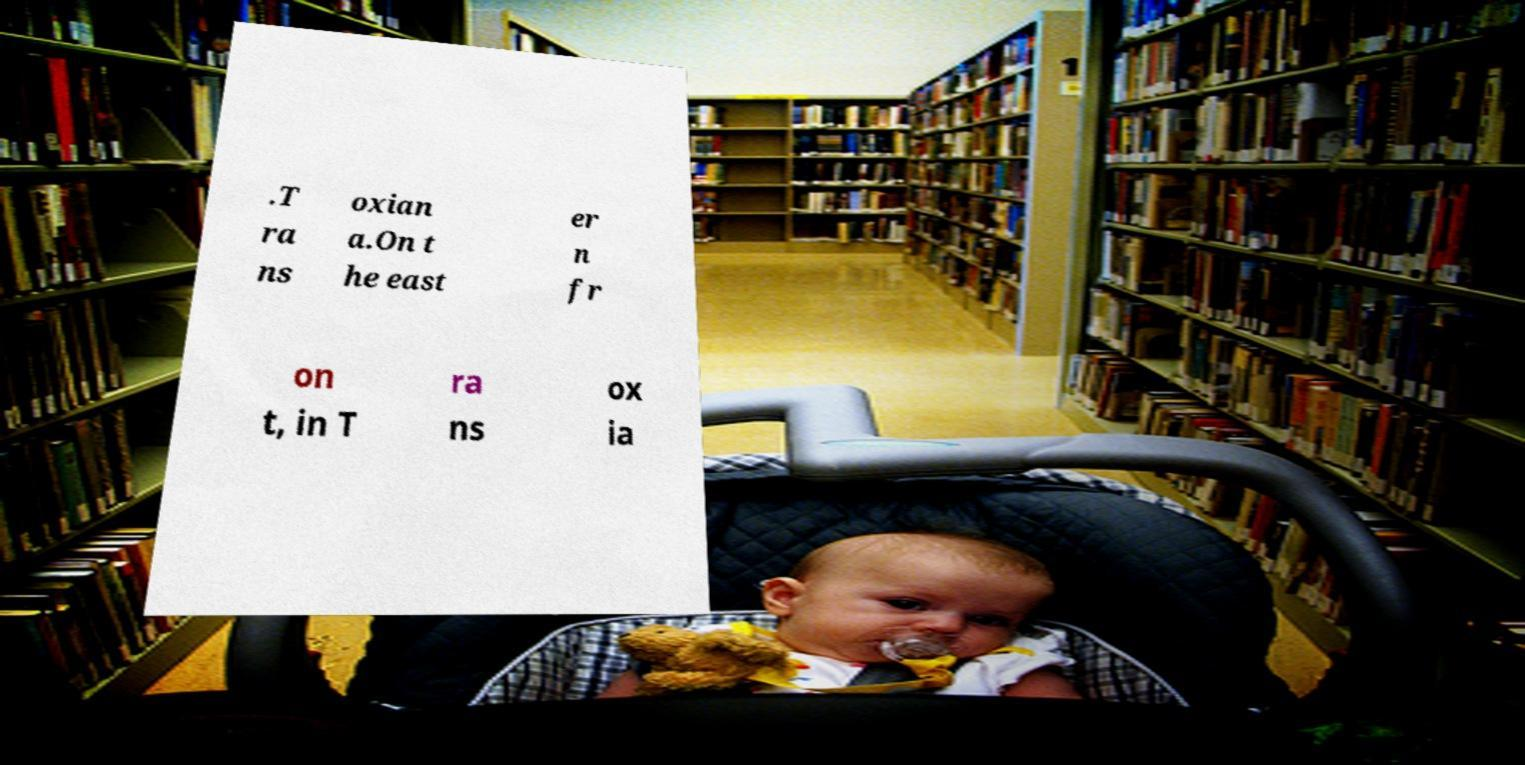For documentation purposes, I need the text within this image transcribed. Could you provide that? .T ra ns oxian a.On t he east er n fr on t, in T ra ns ox ia 